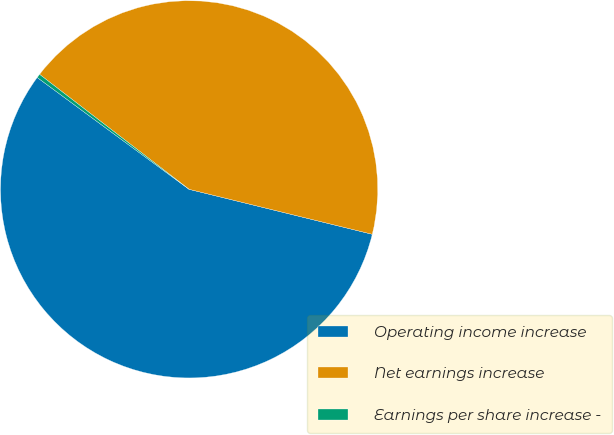<chart> <loc_0><loc_0><loc_500><loc_500><pie_chart><fcel>Operating income increase<fcel>Net earnings increase<fcel>Earnings per share increase -<nl><fcel>56.27%<fcel>43.4%<fcel>0.33%<nl></chart> 